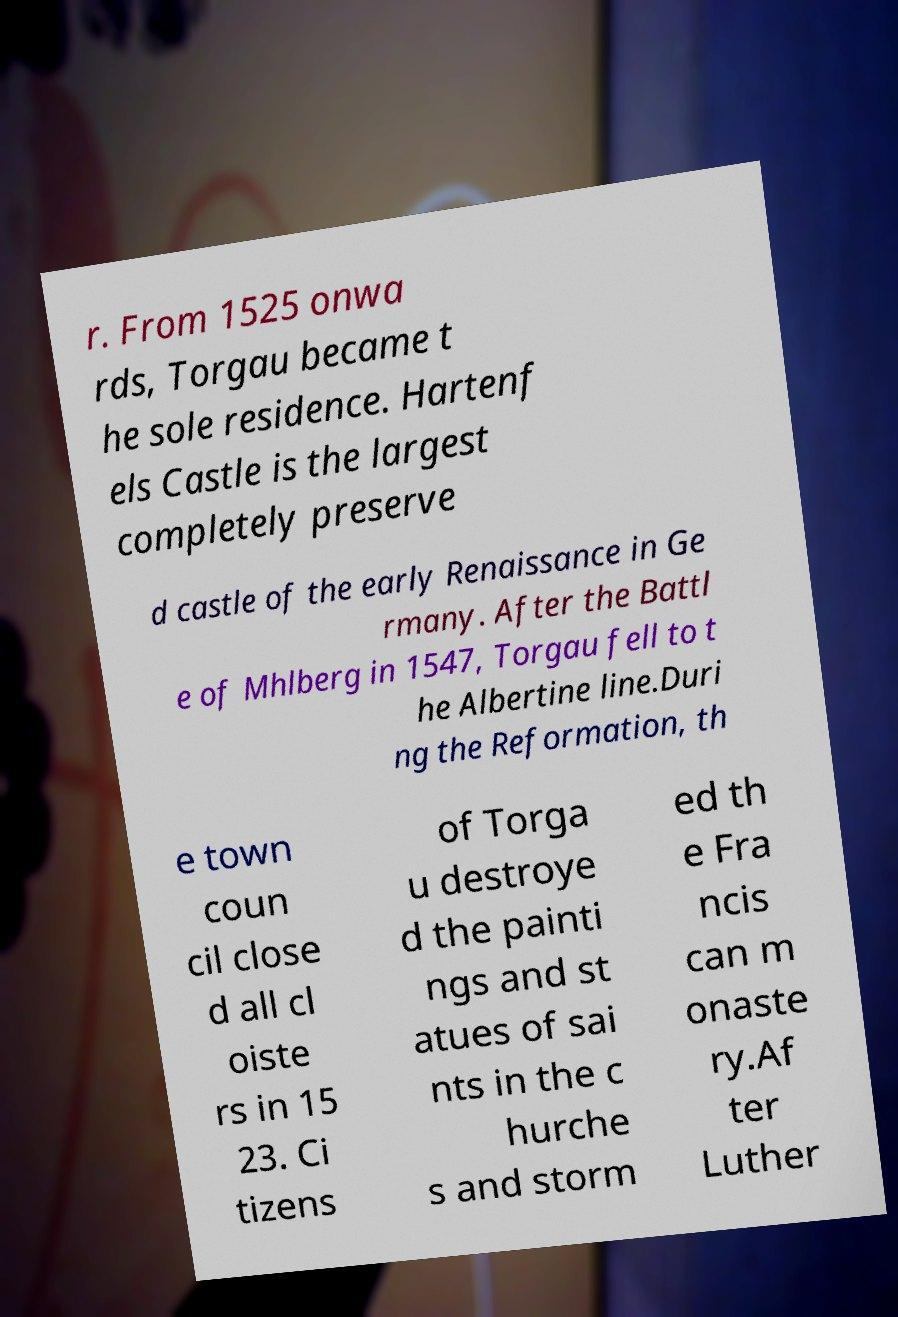There's text embedded in this image that I need extracted. Can you transcribe it verbatim? r. From 1525 onwa rds, Torgau became t he sole residence. Hartenf els Castle is the largest completely preserve d castle of the early Renaissance in Ge rmany. After the Battl e of Mhlberg in 1547, Torgau fell to t he Albertine line.Duri ng the Reformation, th e town coun cil close d all cl oiste rs in 15 23. Ci tizens of Torga u destroye d the painti ngs and st atues of sai nts in the c hurche s and storm ed th e Fra ncis can m onaste ry.Af ter Luther 